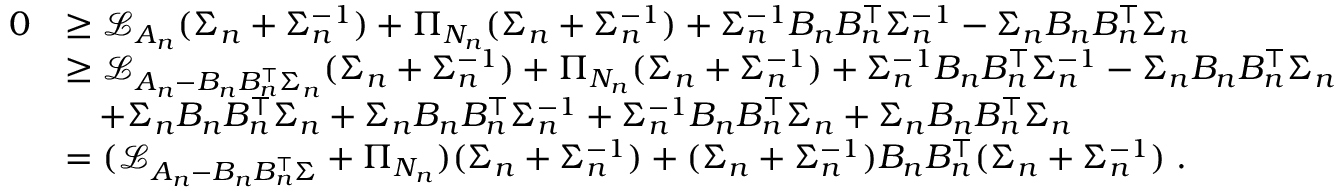<formula> <loc_0><loc_0><loc_500><loc_500>\begin{array} { r l } { 0 } & { \geq \mathcal { L } _ { A _ { n } } ( \Sigma _ { n } + \Sigma _ { n } ^ { - 1 } ) + \Pi _ { N _ { n } } ( \Sigma _ { n } + \Sigma _ { n } ^ { - 1 } ) + \Sigma _ { n } ^ { - 1 } B _ { n } B _ { n } ^ { \top } \Sigma _ { n } ^ { - 1 } - \Sigma _ { n } B _ { n } B _ { n } ^ { \top } \Sigma _ { n } } \\ & { \geq \mathcal { L } _ { A _ { n } - B _ { n } B _ { n } ^ { \top } \Sigma _ { n } } ( \Sigma _ { n } + \Sigma _ { n } ^ { - 1 } ) + \Pi _ { N _ { n } } ( \Sigma _ { n } + \Sigma _ { n } ^ { - 1 } ) + \Sigma _ { n } ^ { - 1 } B _ { n } B _ { n } ^ { \top } \Sigma _ { n } ^ { - 1 } - \Sigma _ { n } B _ { n } B _ { n } ^ { \top } \Sigma _ { n } } \\ & { \quad + \Sigma _ { n } B _ { n } B _ { n } ^ { \top } \Sigma _ { n } + \Sigma _ { n } B _ { n } B _ { n } ^ { \top } \Sigma _ { n } ^ { - 1 } + \Sigma _ { n } ^ { - 1 } B _ { n } B _ { n } ^ { \top } \Sigma _ { n } + \Sigma _ { n } B _ { n } B _ { n } ^ { \top } \Sigma _ { n } } \\ & { = ( \mathcal { L } _ { A _ { n } - B _ { n } B _ { n } ^ { \top } \Sigma } + \Pi _ { N _ { n } } ) ( \Sigma _ { n } + \Sigma _ { n } ^ { - 1 } ) + ( \Sigma _ { n } + \Sigma _ { n } ^ { - 1 } ) B _ { n } B _ { n } ^ { \top } ( \Sigma _ { n } + \Sigma _ { n } ^ { - 1 } ) \, . } \end{array}</formula> 